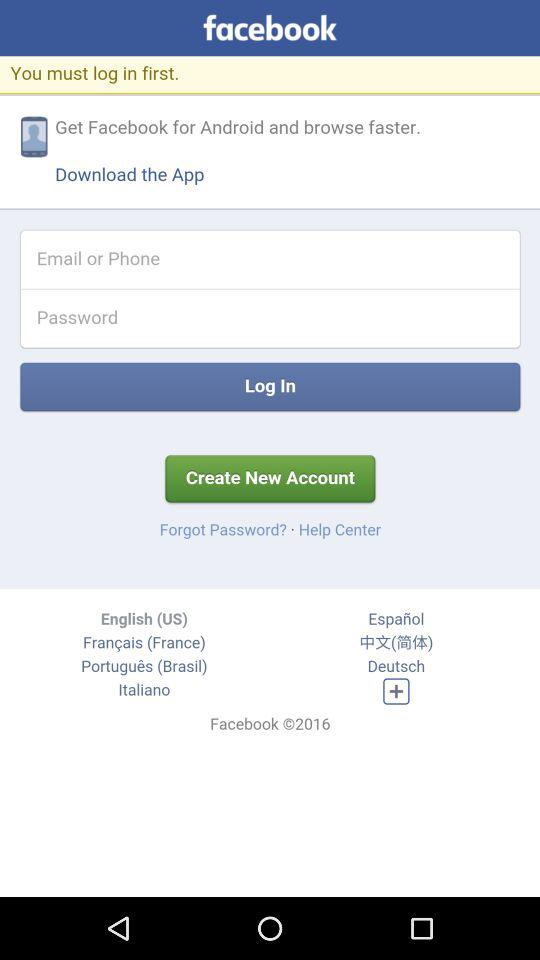What is the name of the application? The name of the application is "facebook". 